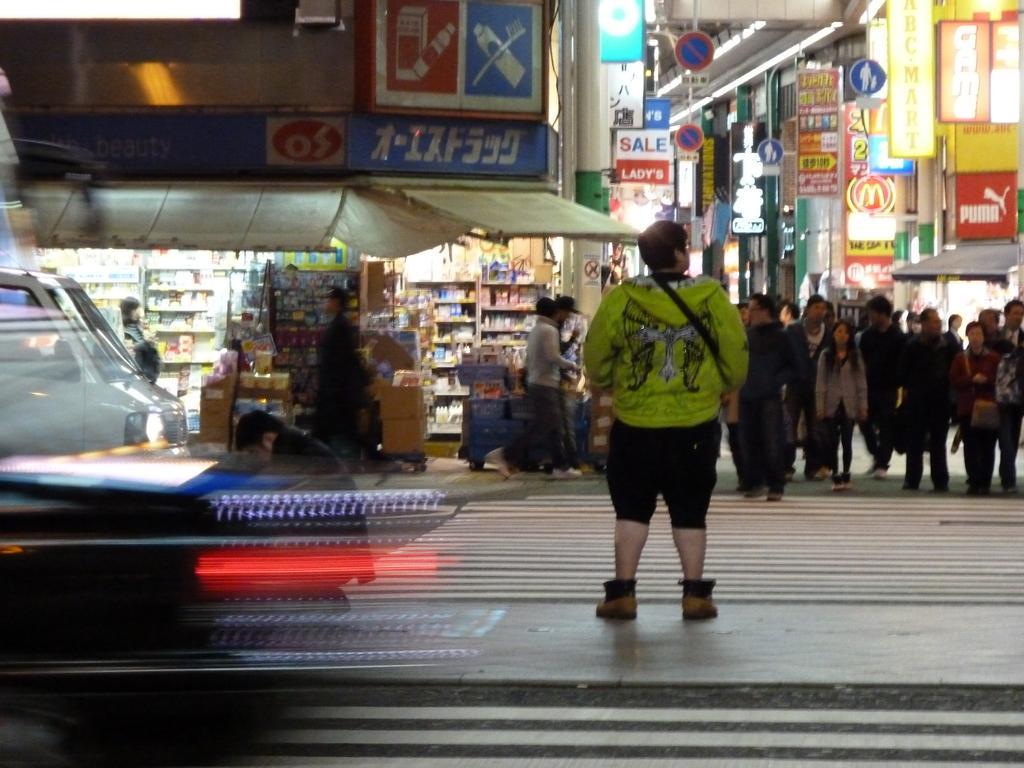In one or two sentences, can you explain what this image depicts? In this image a person is standing on the pavement. Beside him there is a person. Left side there are few vehicles. Right side few persons are standing and few persons are walking on the pavement. Left side there is a shop having racks which are filled with objects. Right side there are few buildings. 